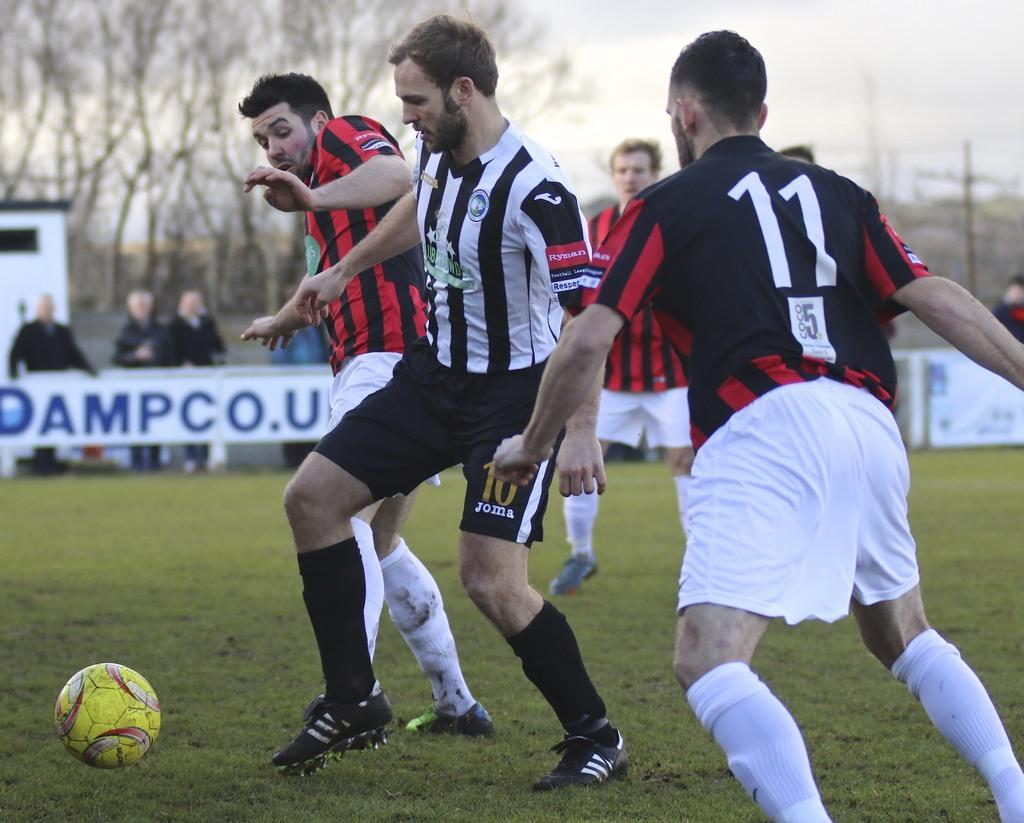<image>
Create a compact narrative representing the image presented. A soccer player wearing no. 10 shorts is in between two players trying to get the ball from him. 